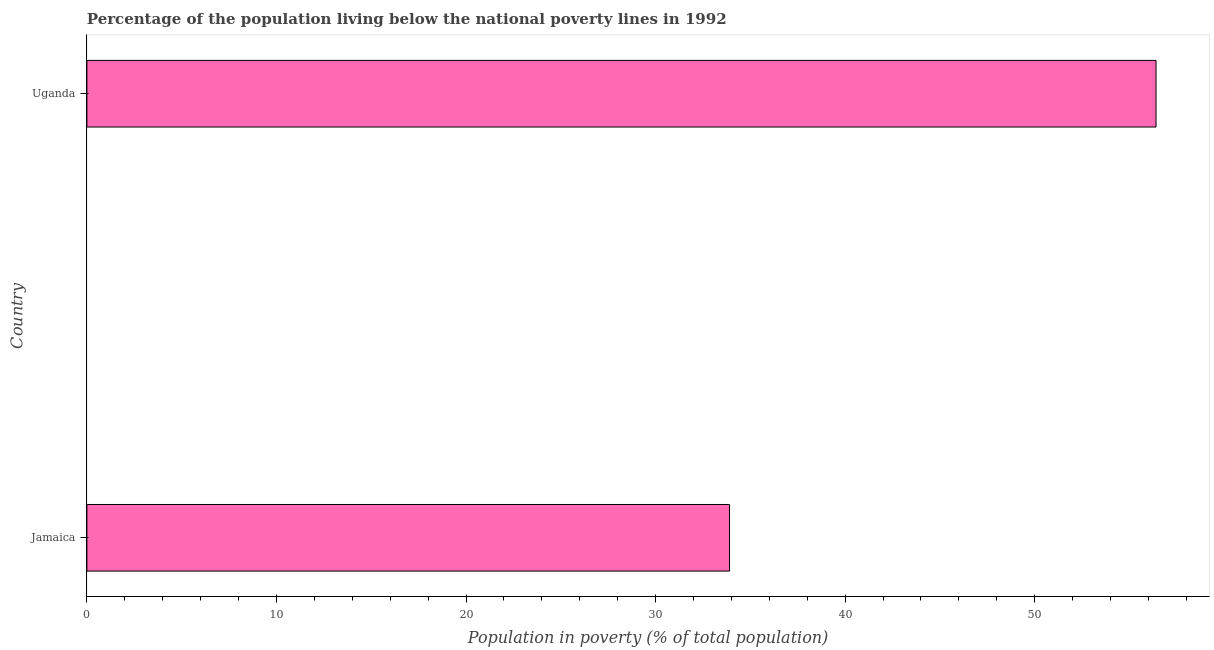Does the graph contain any zero values?
Offer a terse response. No. Does the graph contain grids?
Offer a terse response. No. What is the title of the graph?
Ensure brevity in your answer.  Percentage of the population living below the national poverty lines in 1992. What is the label or title of the X-axis?
Keep it short and to the point. Population in poverty (% of total population). What is the percentage of population living below poverty line in Jamaica?
Keep it short and to the point. 33.9. Across all countries, what is the maximum percentage of population living below poverty line?
Give a very brief answer. 56.4. Across all countries, what is the minimum percentage of population living below poverty line?
Offer a terse response. 33.9. In which country was the percentage of population living below poverty line maximum?
Your answer should be compact. Uganda. In which country was the percentage of population living below poverty line minimum?
Provide a short and direct response. Jamaica. What is the sum of the percentage of population living below poverty line?
Your answer should be compact. 90.3. What is the difference between the percentage of population living below poverty line in Jamaica and Uganda?
Provide a succinct answer. -22.5. What is the average percentage of population living below poverty line per country?
Your answer should be compact. 45.15. What is the median percentage of population living below poverty line?
Your answer should be compact. 45.15. In how many countries, is the percentage of population living below poverty line greater than 52 %?
Offer a terse response. 1. What is the ratio of the percentage of population living below poverty line in Jamaica to that in Uganda?
Keep it short and to the point. 0.6. Is the percentage of population living below poverty line in Jamaica less than that in Uganda?
Keep it short and to the point. Yes. What is the difference between two consecutive major ticks on the X-axis?
Your response must be concise. 10. What is the Population in poverty (% of total population) in Jamaica?
Ensure brevity in your answer.  33.9. What is the Population in poverty (% of total population) in Uganda?
Offer a terse response. 56.4. What is the difference between the Population in poverty (% of total population) in Jamaica and Uganda?
Your answer should be compact. -22.5. What is the ratio of the Population in poverty (% of total population) in Jamaica to that in Uganda?
Your answer should be very brief. 0.6. 